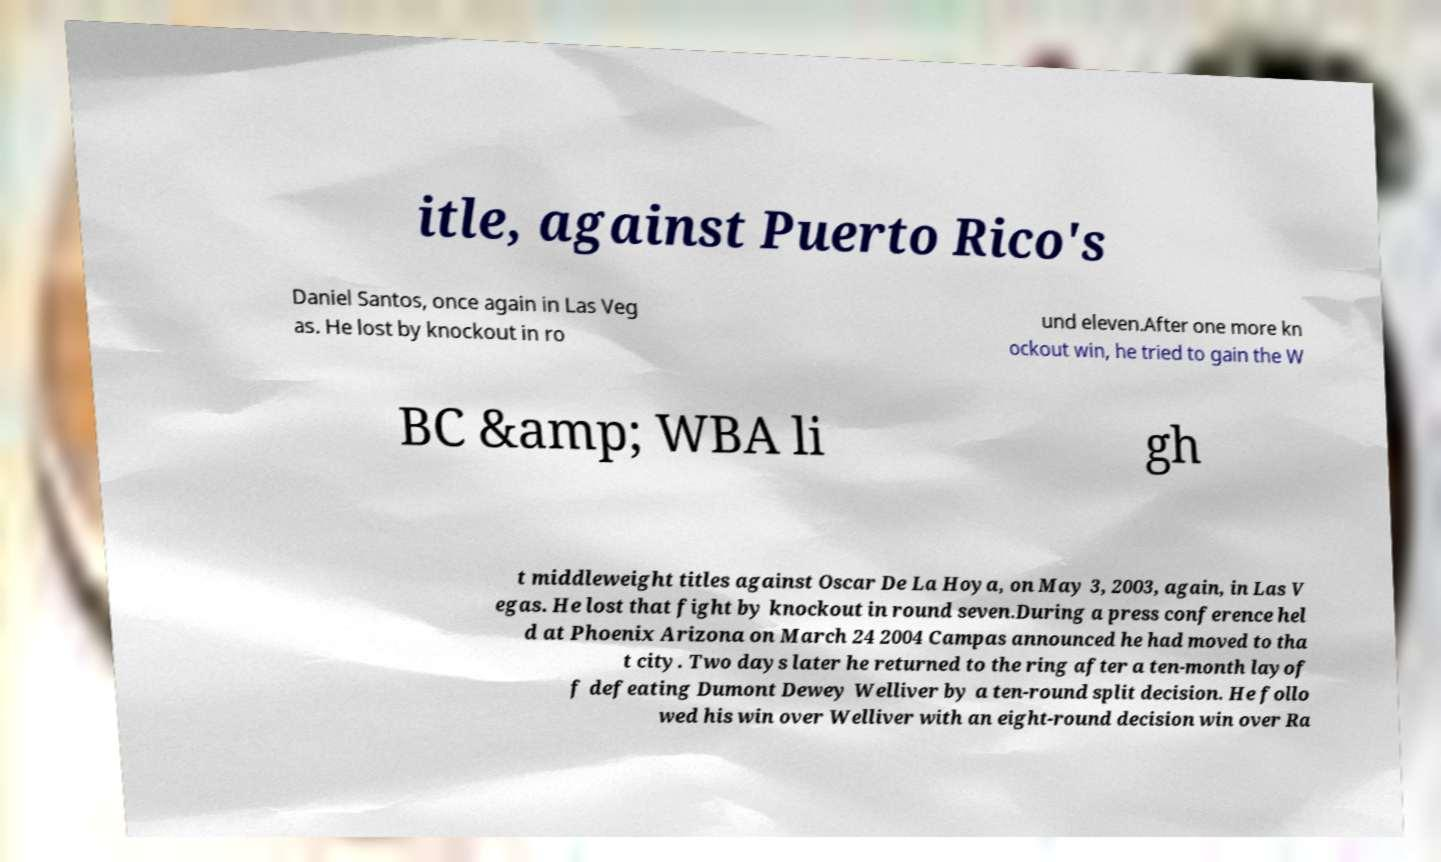What messages or text are displayed in this image? I need them in a readable, typed format. itle, against Puerto Rico's Daniel Santos, once again in Las Veg as. He lost by knockout in ro und eleven.After one more kn ockout win, he tried to gain the W BC &amp; WBA li gh t middleweight titles against Oscar De La Hoya, on May 3, 2003, again, in Las V egas. He lost that fight by knockout in round seven.During a press conference hel d at Phoenix Arizona on March 24 2004 Campas announced he had moved to tha t city. Two days later he returned to the ring after a ten-month layof f defeating Dumont Dewey Welliver by a ten-round split decision. He follo wed his win over Welliver with an eight-round decision win over Ra 